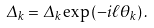Convert formula to latex. <formula><loc_0><loc_0><loc_500><loc_500>\Delta _ { k } = \Delta _ { k } \exp \left ( - i \ell \theta _ { k } \right ) .</formula> 